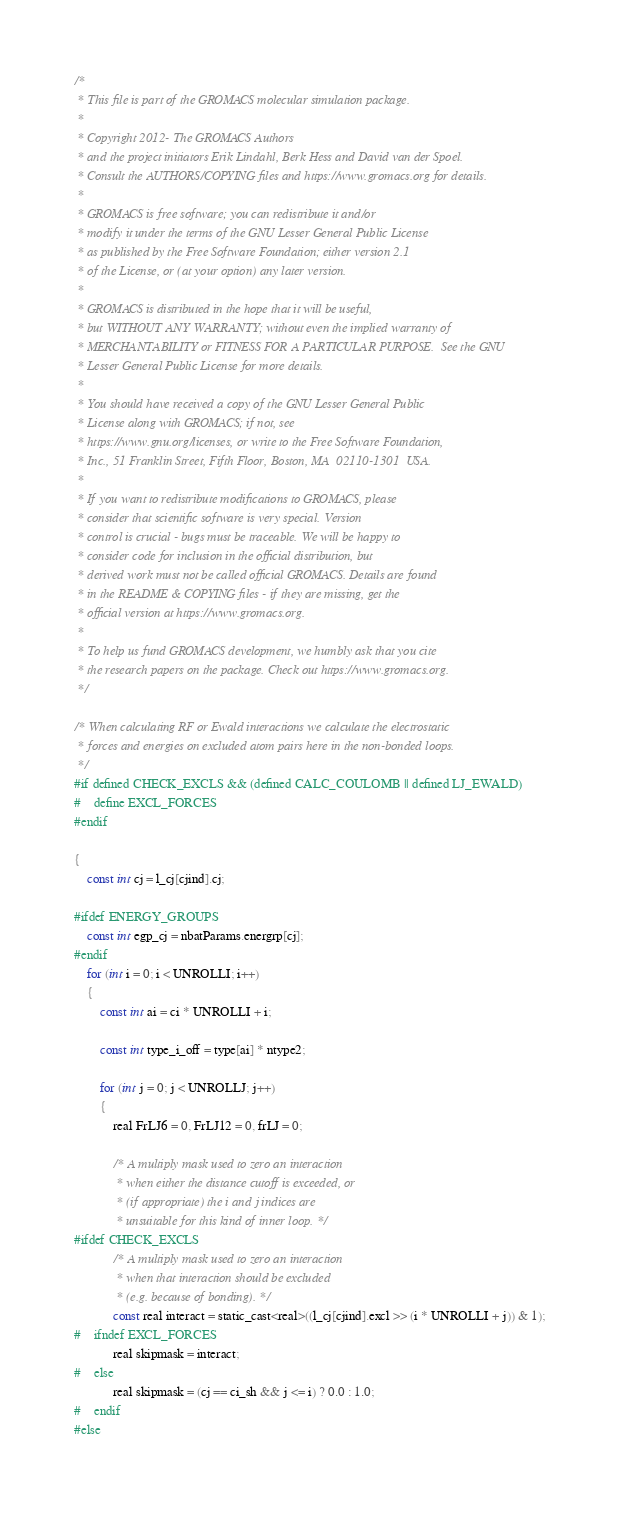Convert code to text. <code><loc_0><loc_0><loc_500><loc_500><_C_>/*
 * This file is part of the GROMACS molecular simulation package.
 *
 * Copyright 2012- The GROMACS Authors
 * and the project initiators Erik Lindahl, Berk Hess and David van der Spoel.
 * Consult the AUTHORS/COPYING files and https://www.gromacs.org for details.
 *
 * GROMACS is free software; you can redistribute it and/or
 * modify it under the terms of the GNU Lesser General Public License
 * as published by the Free Software Foundation; either version 2.1
 * of the License, or (at your option) any later version.
 *
 * GROMACS is distributed in the hope that it will be useful,
 * but WITHOUT ANY WARRANTY; without even the implied warranty of
 * MERCHANTABILITY or FITNESS FOR A PARTICULAR PURPOSE.  See the GNU
 * Lesser General Public License for more details.
 *
 * You should have received a copy of the GNU Lesser General Public
 * License along with GROMACS; if not, see
 * https://www.gnu.org/licenses, or write to the Free Software Foundation,
 * Inc., 51 Franklin Street, Fifth Floor, Boston, MA  02110-1301  USA.
 *
 * If you want to redistribute modifications to GROMACS, please
 * consider that scientific software is very special. Version
 * control is crucial - bugs must be traceable. We will be happy to
 * consider code for inclusion in the official distribution, but
 * derived work must not be called official GROMACS. Details are found
 * in the README & COPYING files - if they are missing, get the
 * official version at https://www.gromacs.org.
 *
 * To help us fund GROMACS development, we humbly ask that you cite
 * the research papers on the package. Check out https://www.gromacs.org.
 */

/* When calculating RF or Ewald interactions we calculate the electrostatic
 * forces and energies on excluded atom pairs here in the non-bonded loops.
 */
#if defined CHECK_EXCLS && (defined CALC_COULOMB || defined LJ_EWALD)
#    define EXCL_FORCES
#endif

{
    const int cj = l_cj[cjind].cj;

#ifdef ENERGY_GROUPS
    const int egp_cj = nbatParams.energrp[cj];
#endif
    for (int i = 0; i < UNROLLI; i++)
    {
        const int ai = ci * UNROLLI + i;

        const int type_i_off = type[ai] * ntype2;

        for (int j = 0; j < UNROLLJ; j++)
        {
            real FrLJ6 = 0, FrLJ12 = 0, frLJ = 0;

            /* A multiply mask used to zero an interaction
             * when either the distance cutoff is exceeded, or
             * (if appropriate) the i and j indices are
             * unsuitable for this kind of inner loop. */
#ifdef CHECK_EXCLS
            /* A multiply mask used to zero an interaction
             * when that interaction should be excluded
             * (e.g. because of bonding). */
            const real interact = static_cast<real>((l_cj[cjind].excl >> (i * UNROLLI + j)) & 1);
#    ifndef EXCL_FORCES
            real skipmask = interact;
#    else
            real skipmask = (cj == ci_sh && j <= i) ? 0.0 : 1.0;
#    endif
#else</code> 